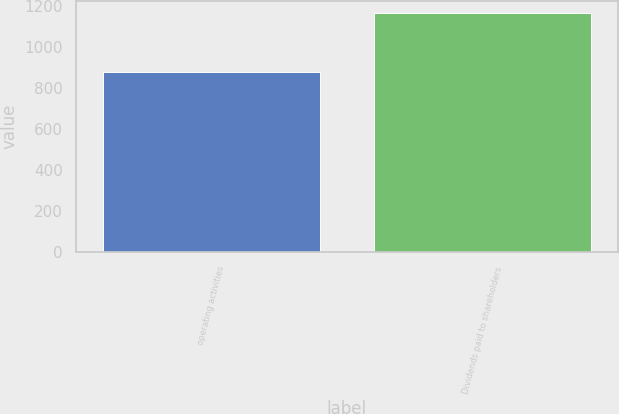Convert chart. <chart><loc_0><loc_0><loc_500><loc_500><bar_chart><fcel>operating activities<fcel>Dividends paid to shareholders<nl><fcel>882<fcel>1170<nl></chart> 